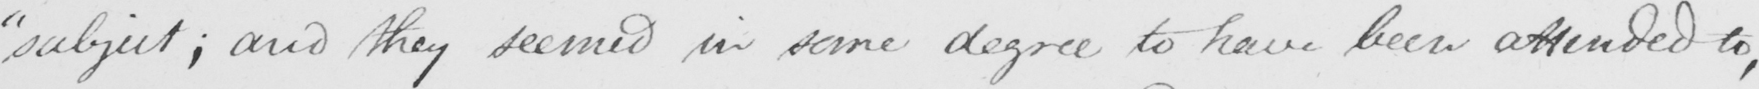Please transcribe the handwritten text in this image. " subject ; and they seemed in some degree to have been attended to , 